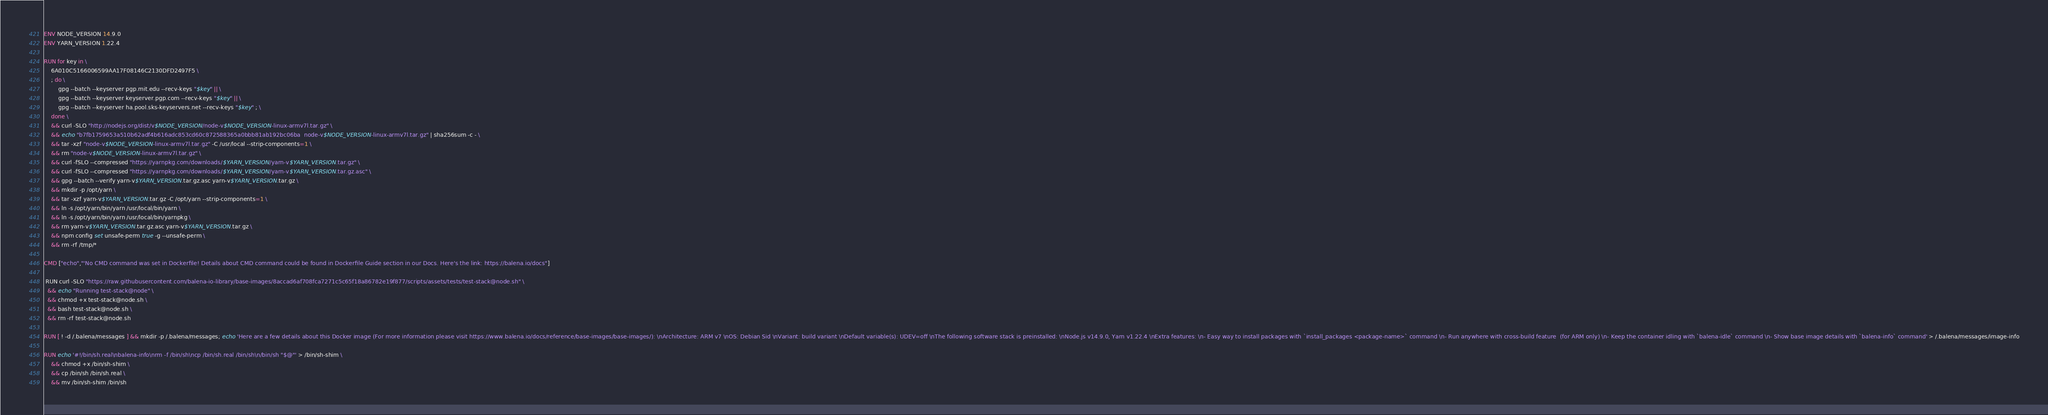Convert code to text. <code><loc_0><loc_0><loc_500><loc_500><_Dockerfile_>ENV NODE_VERSION 14.9.0
ENV YARN_VERSION 1.22.4

RUN for key in \
	6A010C5166006599AA17F08146C2130DFD2497F5 \
	; do \
		gpg --batch --keyserver pgp.mit.edu --recv-keys "$key" || \
		gpg --batch --keyserver keyserver.pgp.com --recv-keys "$key" || \
		gpg --batch --keyserver ha.pool.sks-keyservers.net --recv-keys "$key" ; \
	done \
	&& curl -SLO "http://nodejs.org/dist/v$NODE_VERSION/node-v$NODE_VERSION-linux-armv7l.tar.gz" \
	&& echo "b7fb1759653a510b62adf4b616adc853cd60c872588365a0bbb81ab192bc06ba  node-v$NODE_VERSION-linux-armv7l.tar.gz" | sha256sum -c - \
	&& tar -xzf "node-v$NODE_VERSION-linux-armv7l.tar.gz" -C /usr/local --strip-components=1 \
	&& rm "node-v$NODE_VERSION-linux-armv7l.tar.gz" \
	&& curl -fSLO --compressed "https://yarnpkg.com/downloads/$YARN_VERSION/yarn-v$YARN_VERSION.tar.gz" \
	&& curl -fSLO --compressed "https://yarnpkg.com/downloads/$YARN_VERSION/yarn-v$YARN_VERSION.tar.gz.asc" \
	&& gpg --batch --verify yarn-v$YARN_VERSION.tar.gz.asc yarn-v$YARN_VERSION.tar.gz \
	&& mkdir -p /opt/yarn \
	&& tar -xzf yarn-v$YARN_VERSION.tar.gz -C /opt/yarn --strip-components=1 \
	&& ln -s /opt/yarn/bin/yarn /usr/local/bin/yarn \
	&& ln -s /opt/yarn/bin/yarn /usr/local/bin/yarnpkg \
	&& rm yarn-v$YARN_VERSION.tar.gz.asc yarn-v$YARN_VERSION.tar.gz \
	&& npm config set unsafe-perm true -g --unsafe-perm \
	&& rm -rf /tmp/*

CMD ["echo","'No CMD command was set in Dockerfile! Details about CMD command could be found in Dockerfile Guide section in our Docs. Here's the link: https://balena.io/docs"]

 RUN curl -SLO "https://raw.githubusercontent.com/balena-io-library/base-images/8accad6af708fca7271c5c65f18a86782e19f877/scripts/assets/tests/test-stack@node.sh" \
  && echo "Running test-stack@node" \
  && chmod +x test-stack@node.sh \
  && bash test-stack@node.sh \
  && rm -rf test-stack@node.sh 

RUN [ ! -d /.balena/messages ] && mkdir -p /.balena/messages; echo 'Here are a few details about this Docker image (For more information please visit https://www.balena.io/docs/reference/base-images/base-images/): \nArchitecture: ARM v7 \nOS: Debian Sid \nVariant: build variant \nDefault variable(s): UDEV=off \nThe following software stack is preinstalled: \nNode.js v14.9.0, Yarn v1.22.4 \nExtra features: \n- Easy way to install packages with `install_packages <package-name>` command \n- Run anywhere with cross-build feature  (for ARM only) \n- Keep the container idling with `balena-idle` command \n- Show base image details with `balena-info` command' > /.balena/messages/image-info

RUN echo '#!/bin/sh.real\nbalena-info\nrm -f /bin/sh\ncp /bin/sh.real /bin/sh\n/bin/sh "$@"' > /bin/sh-shim \
	&& chmod +x /bin/sh-shim \
	&& cp /bin/sh /bin/sh.real \
	&& mv /bin/sh-shim /bin/sh</code> 